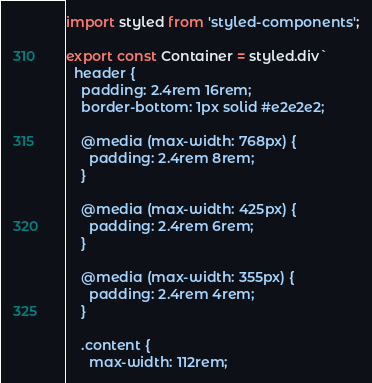Convert code to text. <code><loc_0><loc_0><loc_500><loc_500><_TypeScript_>import styled from 'styled-components';

export const Container = styled.div`
  header {
    padding: 2.4rem 16rem;
    border-bottom: 1px solid #e2e2e2;

    @media (max-width: 768px) {
      padding: 2.4rem 8rem;
    }

    @media (max-width: 425px) {
      padding: 2.4rem 6rem;
    }

    @media (max-width: 355px) {
      padding: 2.4rem 4rem;
    }

    .content {
      max-width: 112rem;</code> 